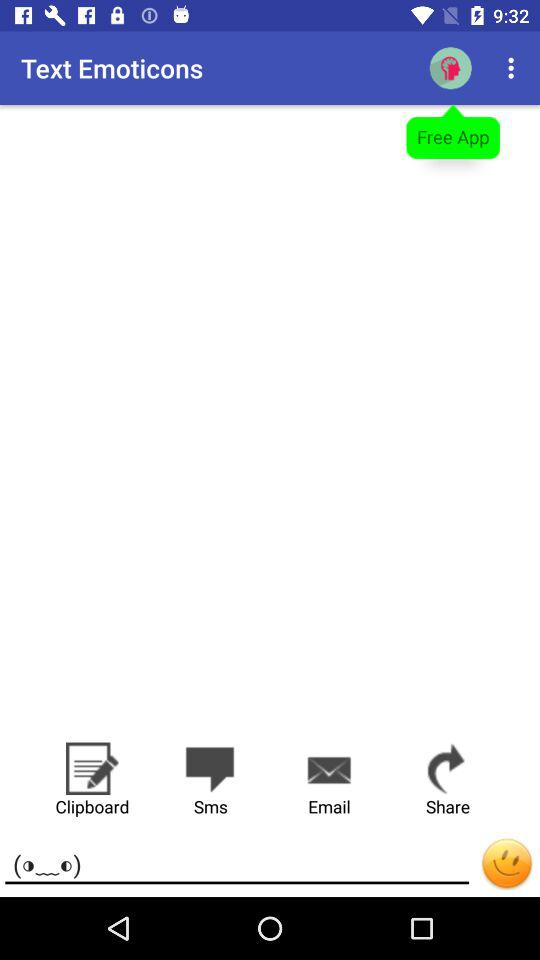What is the name of the application? The name of the application is "Text Emoticons". 